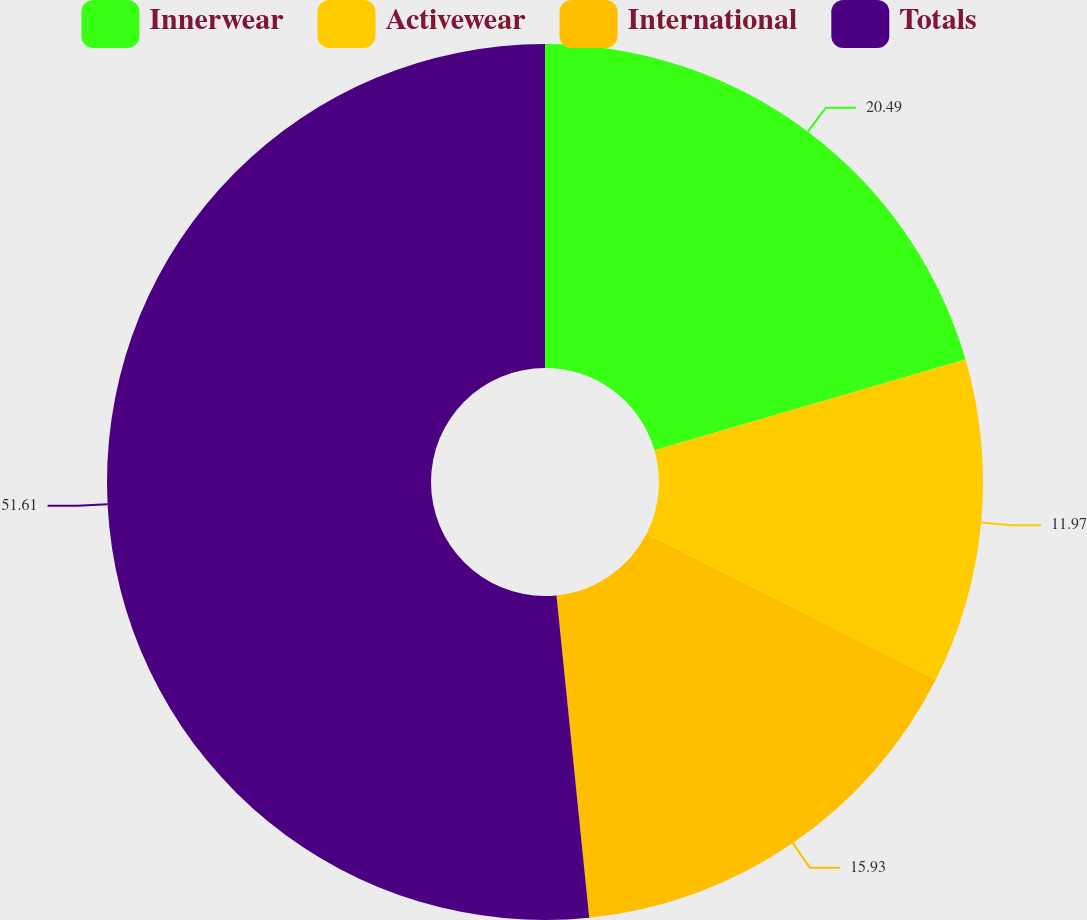Convert chart. <chart><loc_0><loc_0><loc_500><loc_500><pie_chart><fcel>Innerwear<fcel>Activewear<fcel>International<fcel>Totals<nl><fcel>20.49%<fcel>11.97%<fcel>15.93%<fcel>51.61%<nl></chart> 